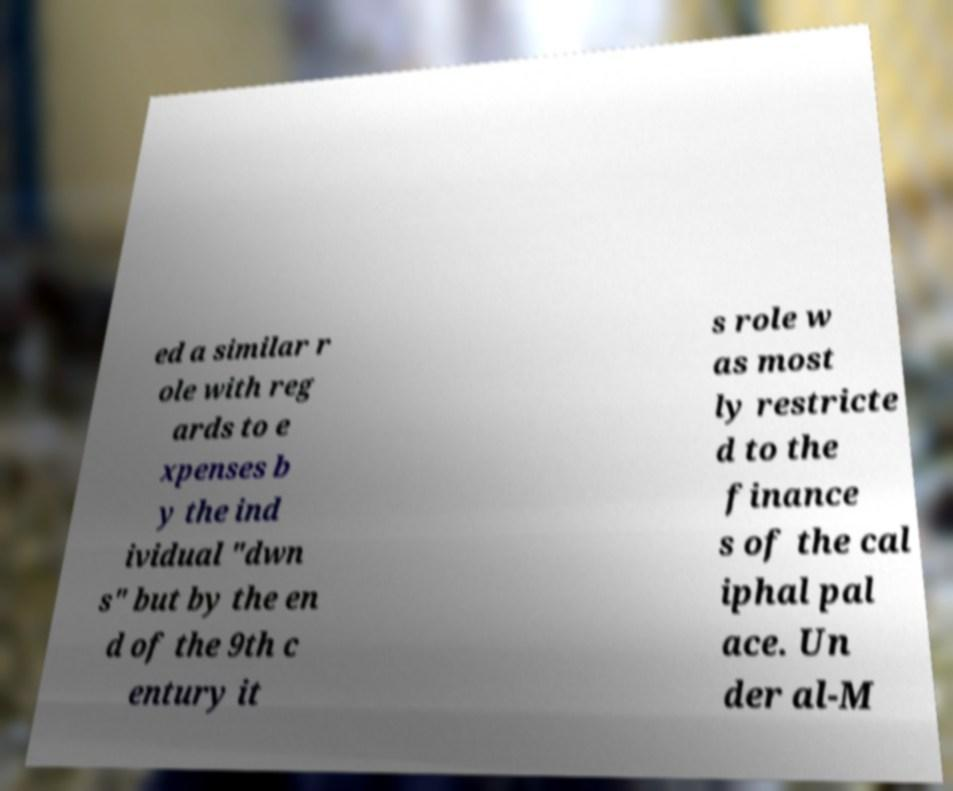Please read and relay the text visible in this image. What does it say? ed a similar r ole with reg ards to e xpenses b y the ind ividual "dwn s" but by the en d of the 9th c entury it s role w as most ly restricte d to the finance s of the cal iphal pal ace. Un der al-M 